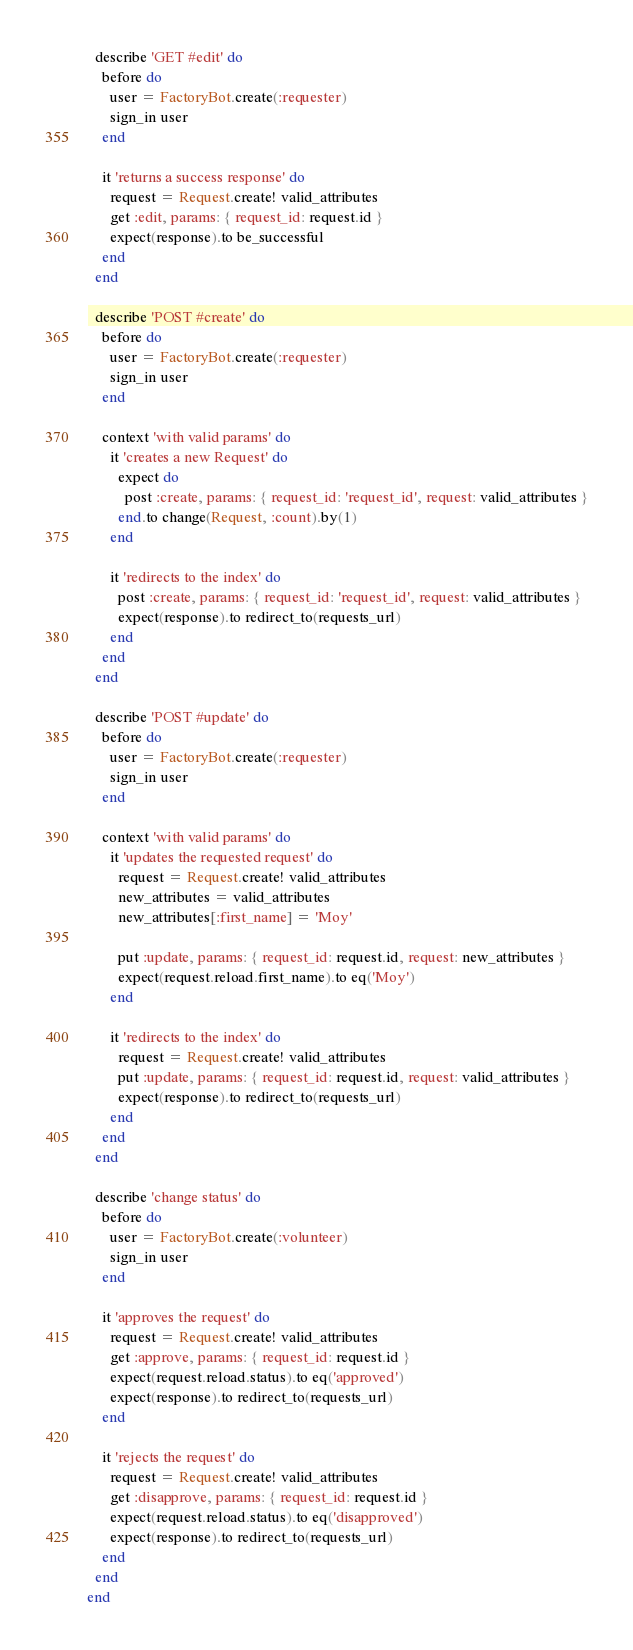Convert code to text. <code><loc_0><loc_0><loc_500><loc_500><_Ruby_>  describe 'GET #edit' do
    before do
      user = FactoryBot.create(:requester)
      sign_in user
    end

    it 'returns a success response' do
      request = Request.create! valid_attributes
      get :edit, params: { request_id: request.id }
      expect(response).to be_successful
    end
  end

  describe 'POST #create' do
    before do
      user = FactoryBot.create(:requester)
      sign_in user
    end

    context 'with valid params' do
      it 'creates a new Request' do
        expect do
          post :create, params: { request_id: 'request_id', request: valid_attributes }
        end.to change(Request, :count).by(1)
      end

      it 'redirects to the index' do
        post :create, params: { request_id: 'request_id', request: valid_attributes }
        expect(response).to redirect_to(requests_url)
      end
    end
  end

  describe 'POST #update' do
    before do
      user = FactoryBot.create(:requester)
      sign_in user
    end

    context 'with valid params' do
      it 'updates the requested request' do
        request = Request.create! valid_attributes
        new_attributes = valid_attributes
        new_attributes[:first_name] = 'Moy'

        put :update, params: { request_id: request.id, request: new_attributes }
        expect(request.reload.first_name).to eq('Moy')
      end

      it 'redirects to the index' do
        request = Request.create! valid_attributes
        put :update, params: { request_id: request.id, request: valid_attributes }
        expect(response).to redirect_to(requests_url)
      end
    end
  end

  describe 'change status' do
    before do
      user = FactoryBot.create(:volunteer)
      sign_in user
    end

    it 'approves the request' do
      request = Request.create! valid_attributes
      get :approve, params: { request_id: request.id }
      expect(request.reload.status).to eq('approved')
      expect(response).to redirect_to(requests_url)
    end

    it 'rejects the request' do
      request = Request.create! valid_attributes
      get :disapprove, params: { request_id: request.id }
      expect(request.reload.status).to eq('disapproved')
      expect(response).to redirect_to(requests_url)
    end
  end
end
</code> 